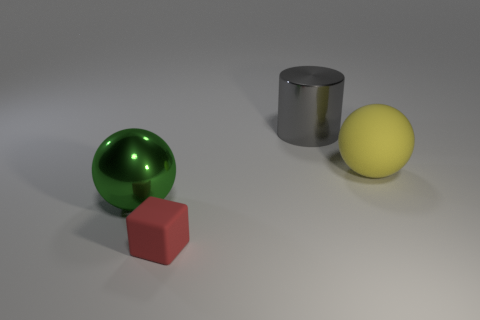What shape is the yellow rubber object that is the same size as the green shiny sphere? The yellow rubber object is also a sphere, presenting a smooth and evenly rounded surface similar to the green sphere. 